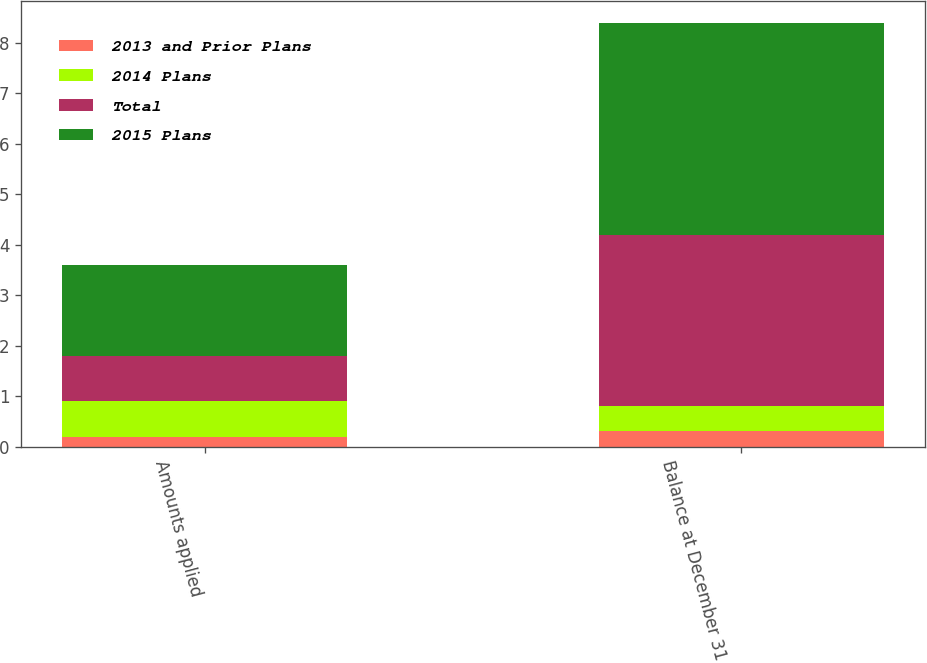Convert chart to OTSL. <chart><loc_0><loc_0><loc_500><loc_500><stacked_bar_chart><ecel><fcel>Amounts applied<fcel>Balance at December 31 2015<nl><fcel>2013 and Prior Plans<fcel>0.2<fcel>0.3<nl><fcel>2014 Plans<fcel>0.7<fcel>0.5<nl><fcel>Total<fcel>0.9<fcel>3.4<nl><fcel>2015 Plans<fcel>1.8<fcel>4.2<nl></chart> 